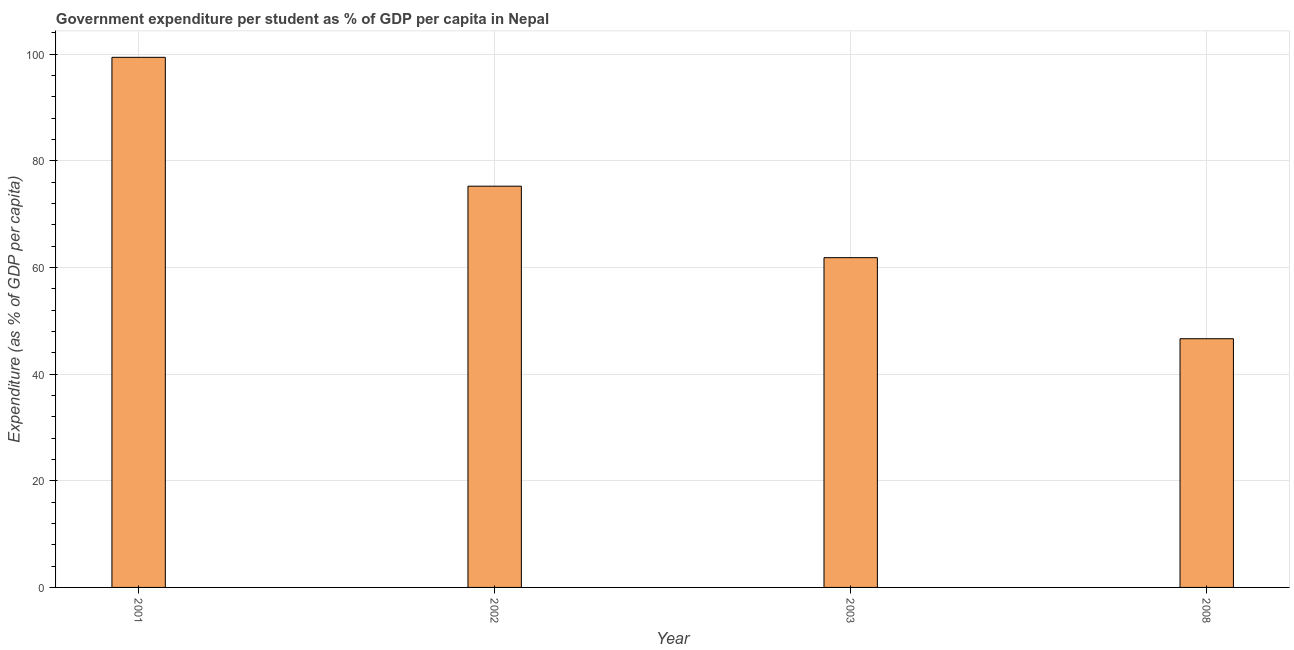What is the title of the graph?
Offer a terse response. Government expenditure per student as % of GDP per capita in Nepal. What is the label or title of the Y-axis?
Provide a succinct answer. Expenditure (as % of GDP per capita). What is the government expenditure per student in 2008?
Offer a very short reply. 46.63. Across all years, what is the maximum government expenditure per student?
Your answer should be very brief. 99.39. Across all years, what is the minimum government expenditure per student?
Your answer should be compact. 46.63. What is the sum of the government expenditure per student?
Provide a short and direct response. 283.09. What is the difference between the government expenditure per student in 2001 and 2008?
Provide a succinct answer. 52.76. What is the average government expenditure per student per year?
Your answer should be very brief. 70.77. What is the median government expenditure per student?
Your response must be concise. 68.53. What is the ratio of the government expenditure per student in 2001 to that in 2008?
Provide a short and direct response. 2.13. Is the government expenditure per student in 2002 less than that in 2003?
Provide a succinct answer. No. What is the difference between the highest and the second highest government expenditure per student?
Give a very brief answer. 24.16. What is the difference between the highest and the lowest government expenditure per student?
Your answer should be compact. 52.76. In how many years, is the government expenditure per student greater than the average government expenditure per student taken over all years?
Provide a succinct answer. 2. How many bars are there?
Keep it short and to the point. 4. Are all the bars in the graph horizontal?
Make the answer very short. No. How many years are there in the graph?
Offer a terse response. 4. What is the difference between two consecutive major ticks on the Y-axis?
Your response must be concise. 20. Are the values on the major ticks of Y-axis written in scientific E-notation?
Keep it short and to the point. No. What is the Expenditure (as % of GDP per capita) of 2001?
Ensure brevity in your answer.  99.39. What is the Expenditure (as % of GDP per capita) of 2002?
Ensure brevity in your answer.  75.23. What is the Expenditure (as % of GDP per capita) of 2003?
Provide a succinct answer. 61.83. What is the Expenditure (as % of GDP per capita) in 2008?
Your answer should be very brief. 46.63. What is the difference between the Expenditure (as % of GDP per capita) in 2001 and 2002?
Ensure brevity in your answer.  24.16. What is the difference between the Expenditure (as % of GDP per capita) in 2001 and 2003?
Give a very brief answer. 37.56. What is the difference between the Expenditure (as % of GDP per capita) in 2001 and 2008?
Make the answer very short. 52.76. What is the difference between the Expenditure (as % of GDP per capita) in 2002 and 2003?
Make the answer very short. 13.4. What is the difference between the Expenditure (as % of GDP per capita) in 2002 and 2008?
Make the answer very short. 28.6. What is the difference between the Expenditure (as % of GDP per capita) in 2003 and 2008?
Offer a terse response. 15.2. What is the ratio of the Expenditure (as % of GDP per capita) in 2001 to that in 2002?
Make the answer very short. 1.32. What is the ratio of the Expenditure (as % of GDP per capita) in 2001 to that in 2003?
Make the answer very short. 1.61. What is the ratio of the Expenditure (as % of GDP per capita) in 2001 to that in 2008?
Offer a very short reply. 2.13. What is the ratio of the Expenditure (as % of GDP per capita) in 2002 to that in 2003?
Your answer should be very brief. 1.22. What is the ratio of the Expenditure (as % of GDP per capita) in 2002 to that in 2008?
Provide a succinct answer. 1.61. What is the ratio of the Expenditure (as % of GDP per capita) in 2003 to that in 2008?
Make the answer very short. 1.33. 